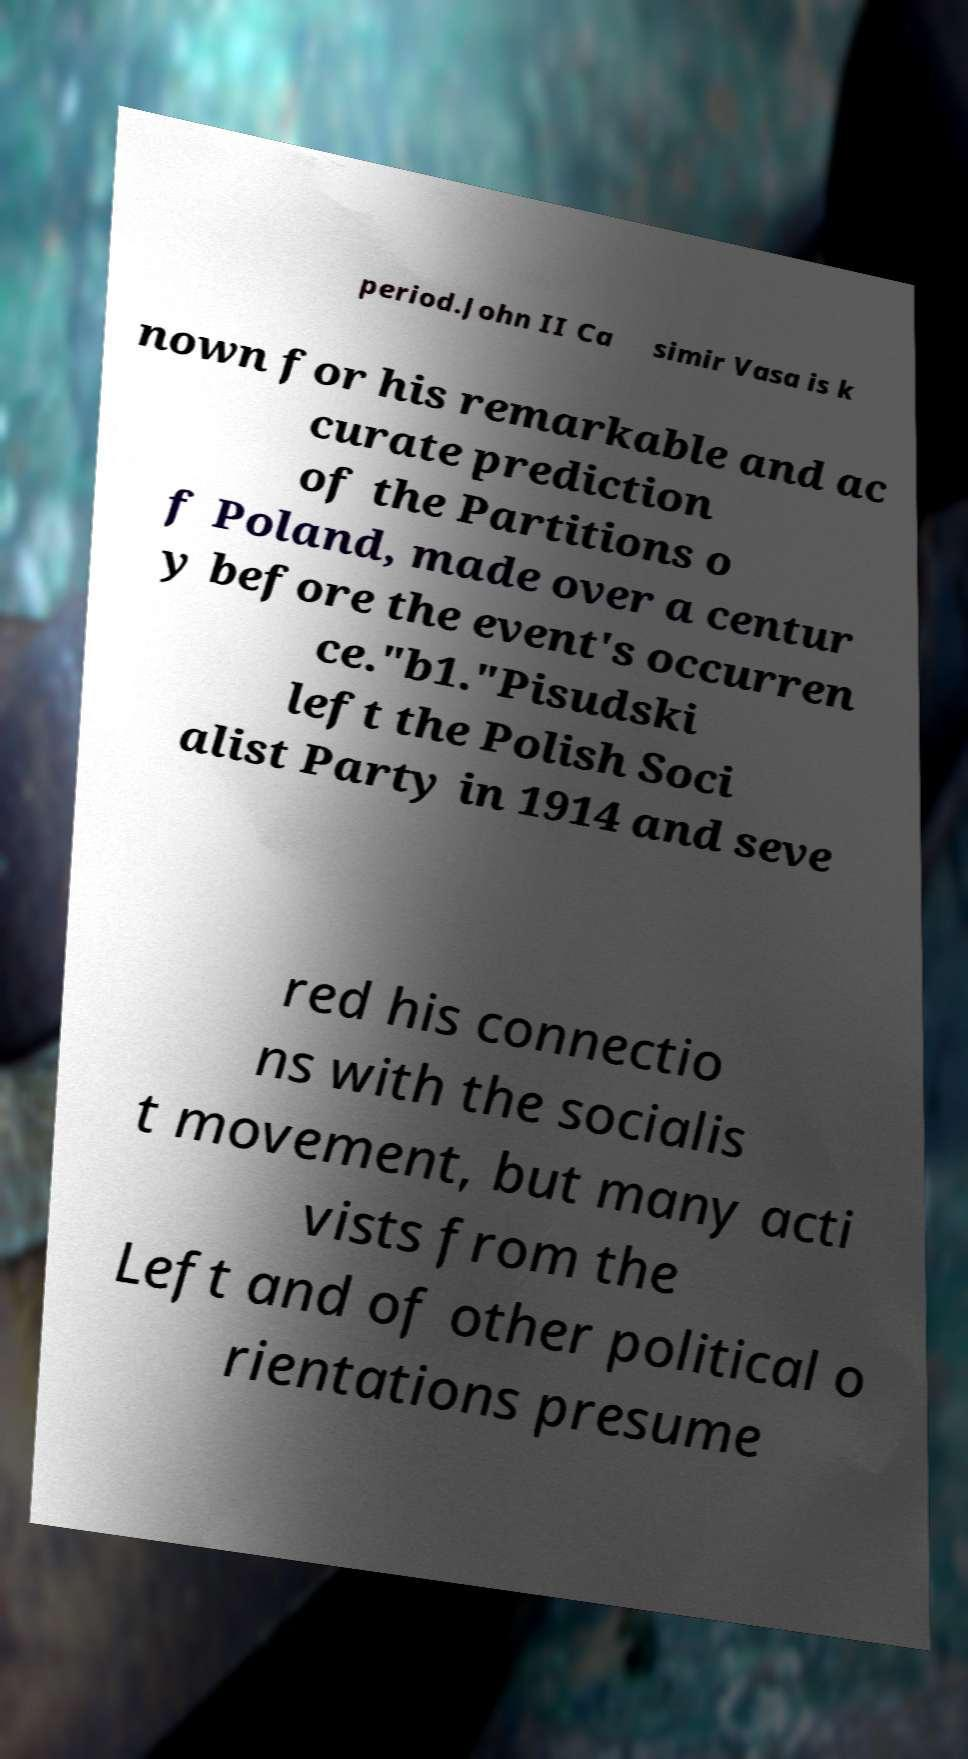I need the written content from this picture converted into text. Can you do that? period.John II Ca simir Vasa is k nown for his remarkable and ac curate prediction of the Partitions o f Poland, made over a centur y before the event's occurren ce."b1."Pisudski left the Polish Soci alist Party in 1914 and seve red his connectio ns with the socialis t movement, but many acti vists from the Left and of other political o rientations presume 